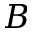<formula> <loc_0><loc_0><loc_500><loc_500>B</formula> 